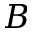<formula> <loc_0><loc_0><loc_500><loc_500>B</formula> 